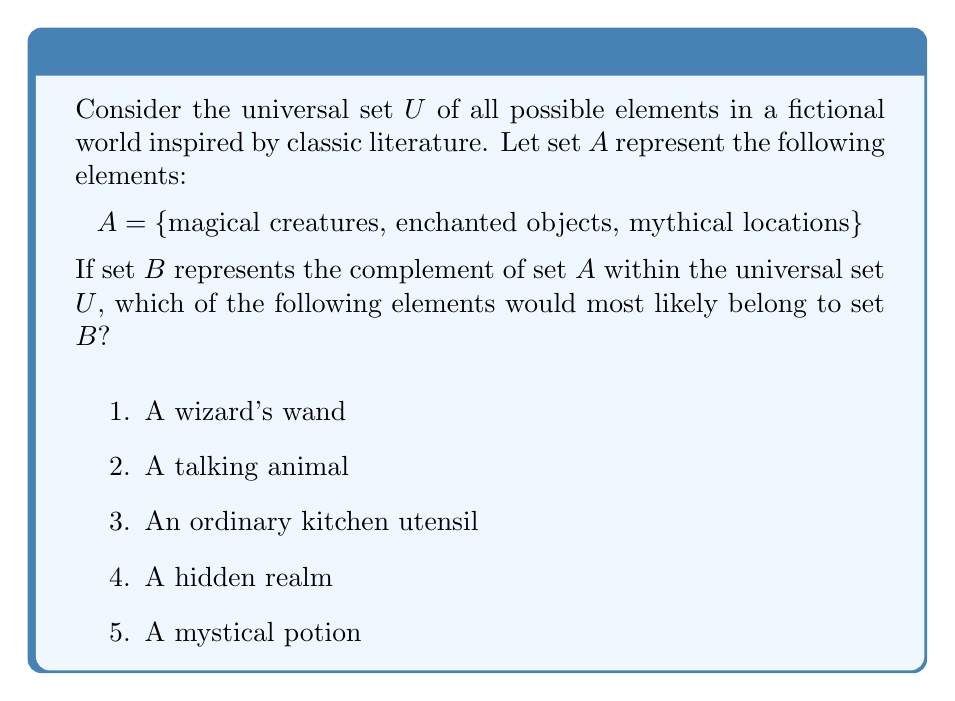Solve this math problem. To solve this problem, we need to understand the concept of complement sets:

1. The complement of set $A$, denoted as $A^c$ or $\overline{A}$, contains all elements in the universal set $U$ that are not in $A$.

2. Mathematically, this is expressed as:
   $B = A^c = \{x \in U : x \notin A\}$

3. Given set $A = \{$magical creatures, enchanted objects, mythical locations$\}$, we need to identify elements that do not fit into these categories.

4. Let's analyze each option:
   a) A wizard's wand: This is an enchanted object, so it belongs to $A$.
   b) A talking animal: This is a magical creature, so it belongs to $A$.
   c) An ordinary kitchen utensil: This is not magical, enchanted, or mythical, so it belongs to $B$.
   d) A hidden realm: This could be considered a mythical location, so it belongs to $A$.
   e) A mystical potion: This is an enchanted object, so it belongs to $A$.

5. The only element that doesn't fit into the categories defined by set $A$ is the ordinary kitchen utensil.

Therefore, the element that most likely belongs to set $B$ (the complement of $A$) is an ordinary kitchen utensil.
Answer: An ordinary kitchen utensil 